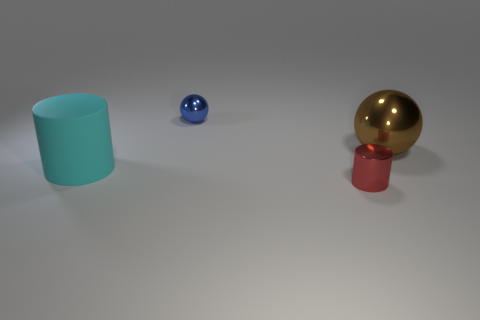Could you guess what the red tiny cylinder is made of? Given the tiny red cylinder's glossy appearance and its similarity to the reflective gold ball, it may be made of a polished metal or a material with a metallic finish. 